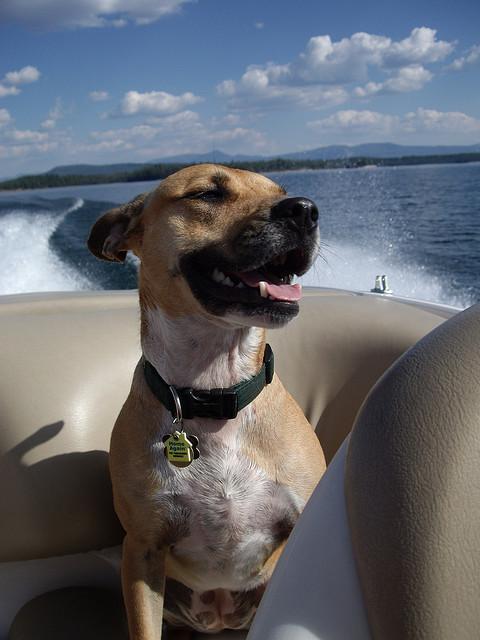How many yellow buses are in the picture?
Give a very brief answer. 0. 